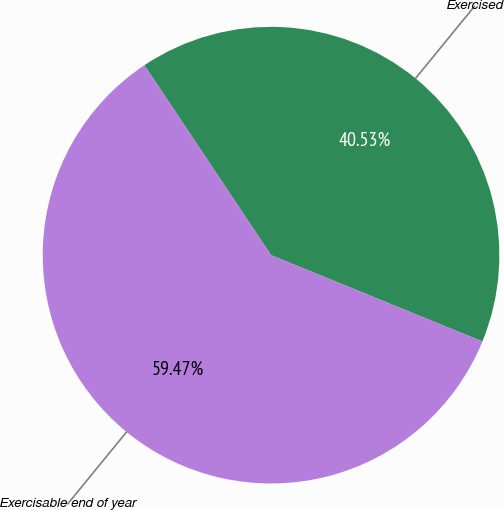Convert chart to OTSL. <chart><loc_0><loc_0><loc_500><loc_500><pie_chart><fcel>Exercised<fcel>Exercisable end of year<nl><fcel>40.53%<fcel>59.47%<nl></chart> 